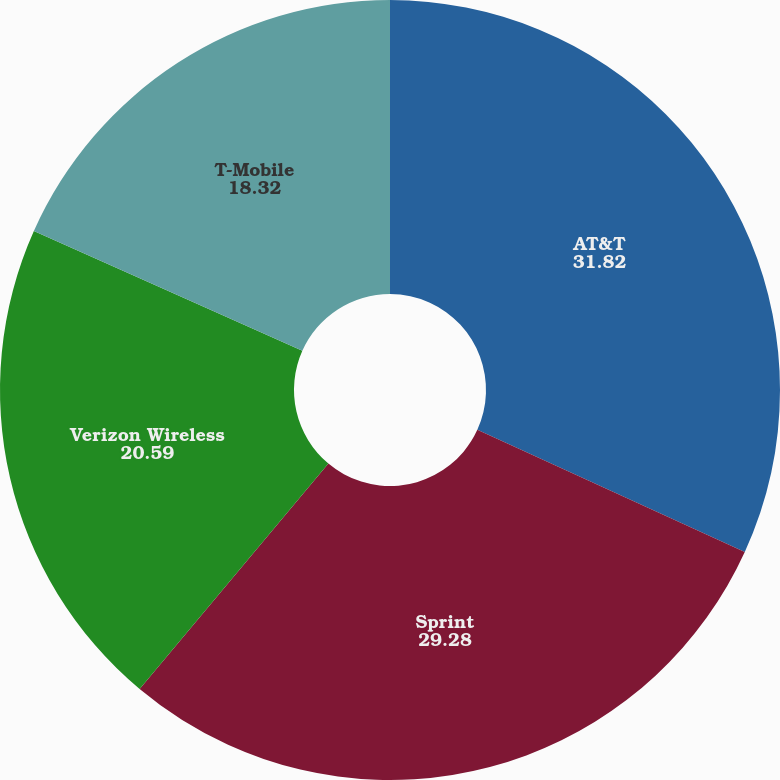Convert chart to OTSL. <chart><loc_0><loc_0><loc_500><loc_500><pie_chart><fcel>AT&T<fcel>Sprint<fcel>Verizon Wireless<fcel>T-Mobile<nl><fcel>31.82%<fcel>29.28%<fcel>20.59%<fcel>18.32%<nl></chart> 